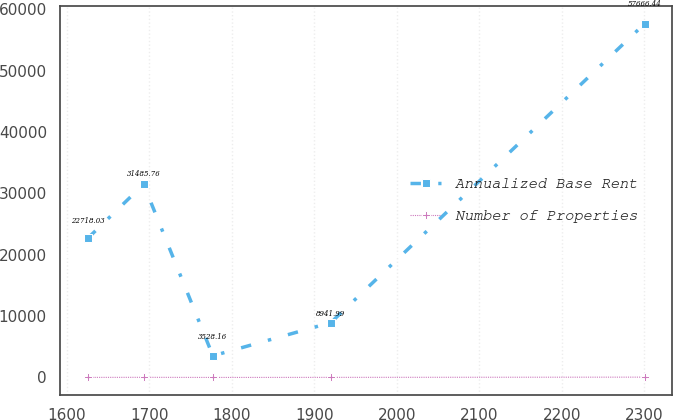Convert chart to OTSL. <chart><loc_0><loc_0><loc_500><loc_500><line_chart><ecel><fcel>Annualized Base Rent<fcel>Number of Properties<nl><fcel>1625.34<fcel>22718<fcel>9.47<nl><fcel>1692.86<fcel>31485.8<fcel>22.78<nl><fcel>1776.91<fcel>3528.16<fcel>2.26<nl><fcel>1919.96<fcel>8941.99<fcel>14.43<nl><fcel>2300.55<fcel>57666.4<fcel>51.88<nl></chart> 